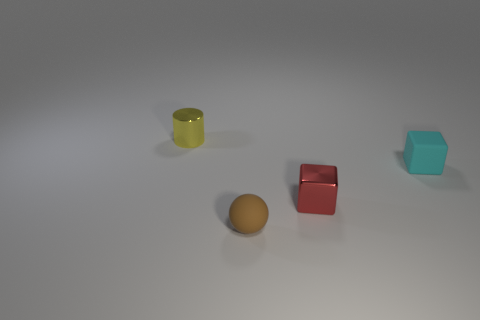Add 3 tiny red objects. How many objects exist? 7 Subtract all cylinders. How many objects are left? 3 Subtract 0 cyan balls. How many objects are left? 4 Subtract all tiny matte objects. Subtract all yellow cylinders. How many objects are left? 1 Add 4 yellow cylinders. How many yellow cylinders are left? 5 Add 4 cyan blocks. How many cyan blocks exist? 5 